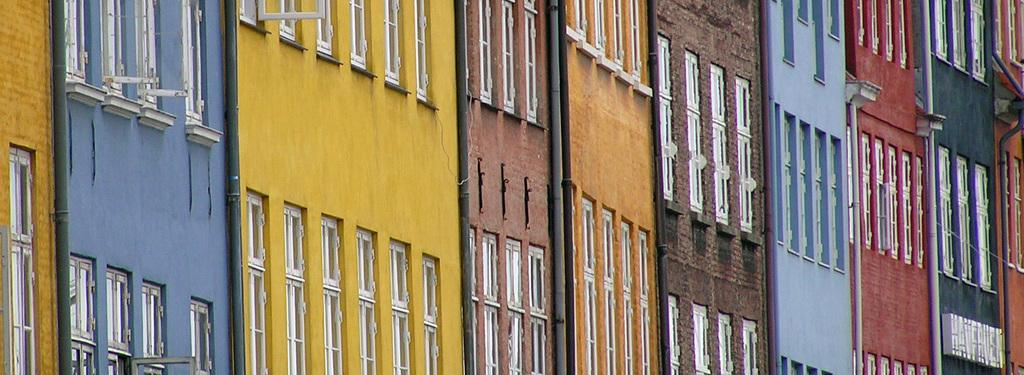What type of structures are present in the image? There are buildings in the image. What architectural features can be seen on the buildings? Windows are visible in the image. What other elements can be seen in the image? There are pipes visible in the image. What type of orange can be seen growing on the sand in the image? There is no orange or sand present in the image; it features buildings, windows, and pipes. How many waves can be seen crashing against the buildings in the image? There are no waves present in the image; it features buildings, windows, and pipes. 